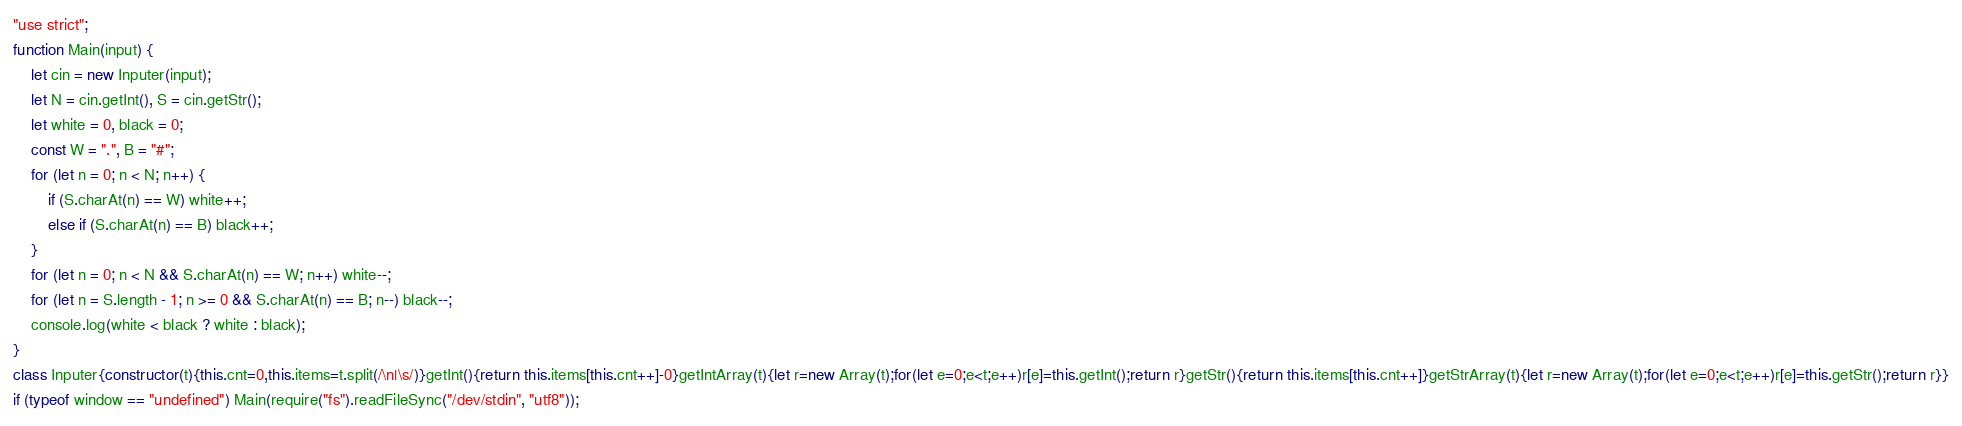<code> <loc_0><loc_0><loc_500><loc_500><_JavaScript_>"use strict";
function Main(input) {
    let cin = new Inputer(input);
    let N = cin.getInt(), S = cin.getStr();
    let white = 0, black = 0;
    const W = ".", B = "#";
    for (let n = 0; n < N; n++) {
        if (S.charAt(n) == W) white++; 
        else if (S.charAt(n) == B) black++;
    }
    for (let n = 0; n < N && S.charAt(n) == W; n++) white--;
    for (let n = S.length - 1; n >= 0 && S.charAt(n) == B; n--) black--;
    console.log(white < black ? white : black);
}
class Inputer{constructor(t){this.cnt=0,this.items=t.split(/\n|\s/)}getInt(){return this.items[this.cnt++]-0}getIntArray(t){let r=new Array(t);for(let e=0;e<t;e++)r[e]=this.getInt();return r}getStr(){return this.items[this.cnt++]}getStrArray(t){let r=new Array(t);for(let e=0;e<t;e++)r[e]=this.getStr();return r}}
if (typeof window == "undefined") Main(require("fs").readFileSync("/dev/stdin", "utf8"));</code> 